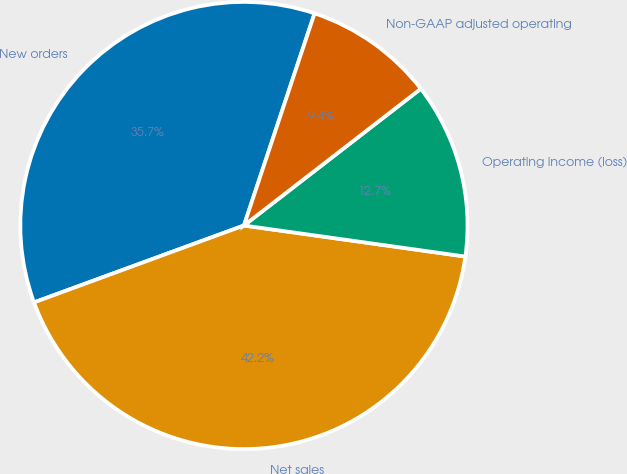Convert chart to OTSL. <chart><loc_0><loc_0><loc_500><loc_500><pie_chart><fcel>New orders<fcel>Net sales<fcel>Operating income (loss)<fcel>Non-GAAP adjusted operating<nl><fcel>35.7%<fcel>42.19%<fcel>12.69%<fcel>9.41%<nl></chart> 